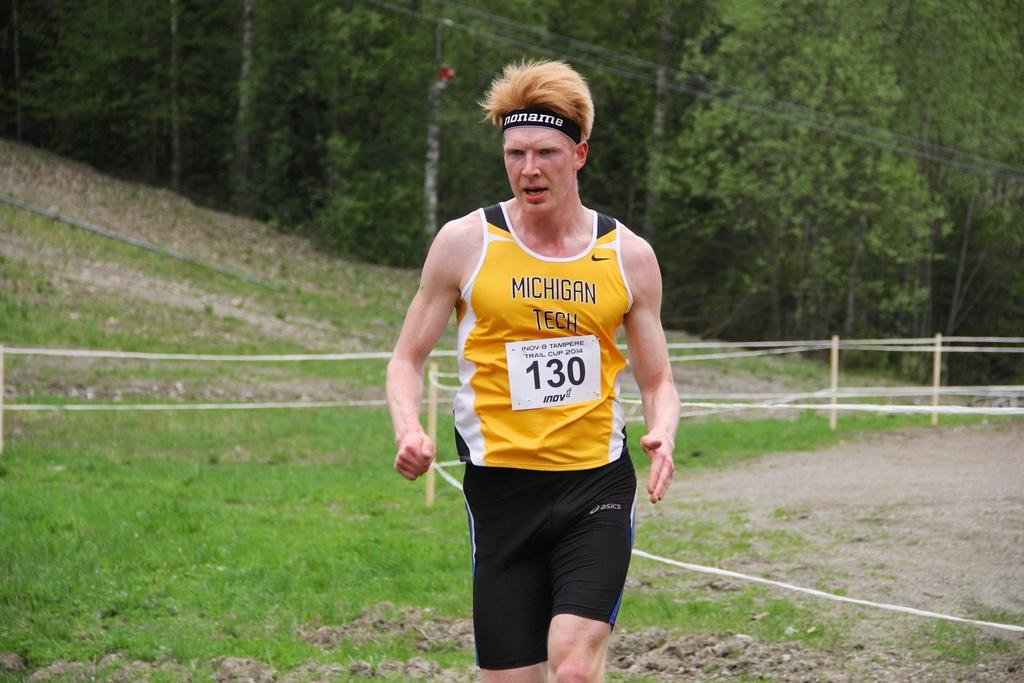<image>
Provide a brief description of the given image. A runner wearing a yellow Michigan Tech shirt 